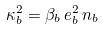Convert formula to latex. <formula><loc_0><loc_0><loc_500><loc_500>\kappa ^ { 2 } _ { b } = \beta _ { b } \, e _ { b } ^ { 2 } \, n _ { b }</formula> 